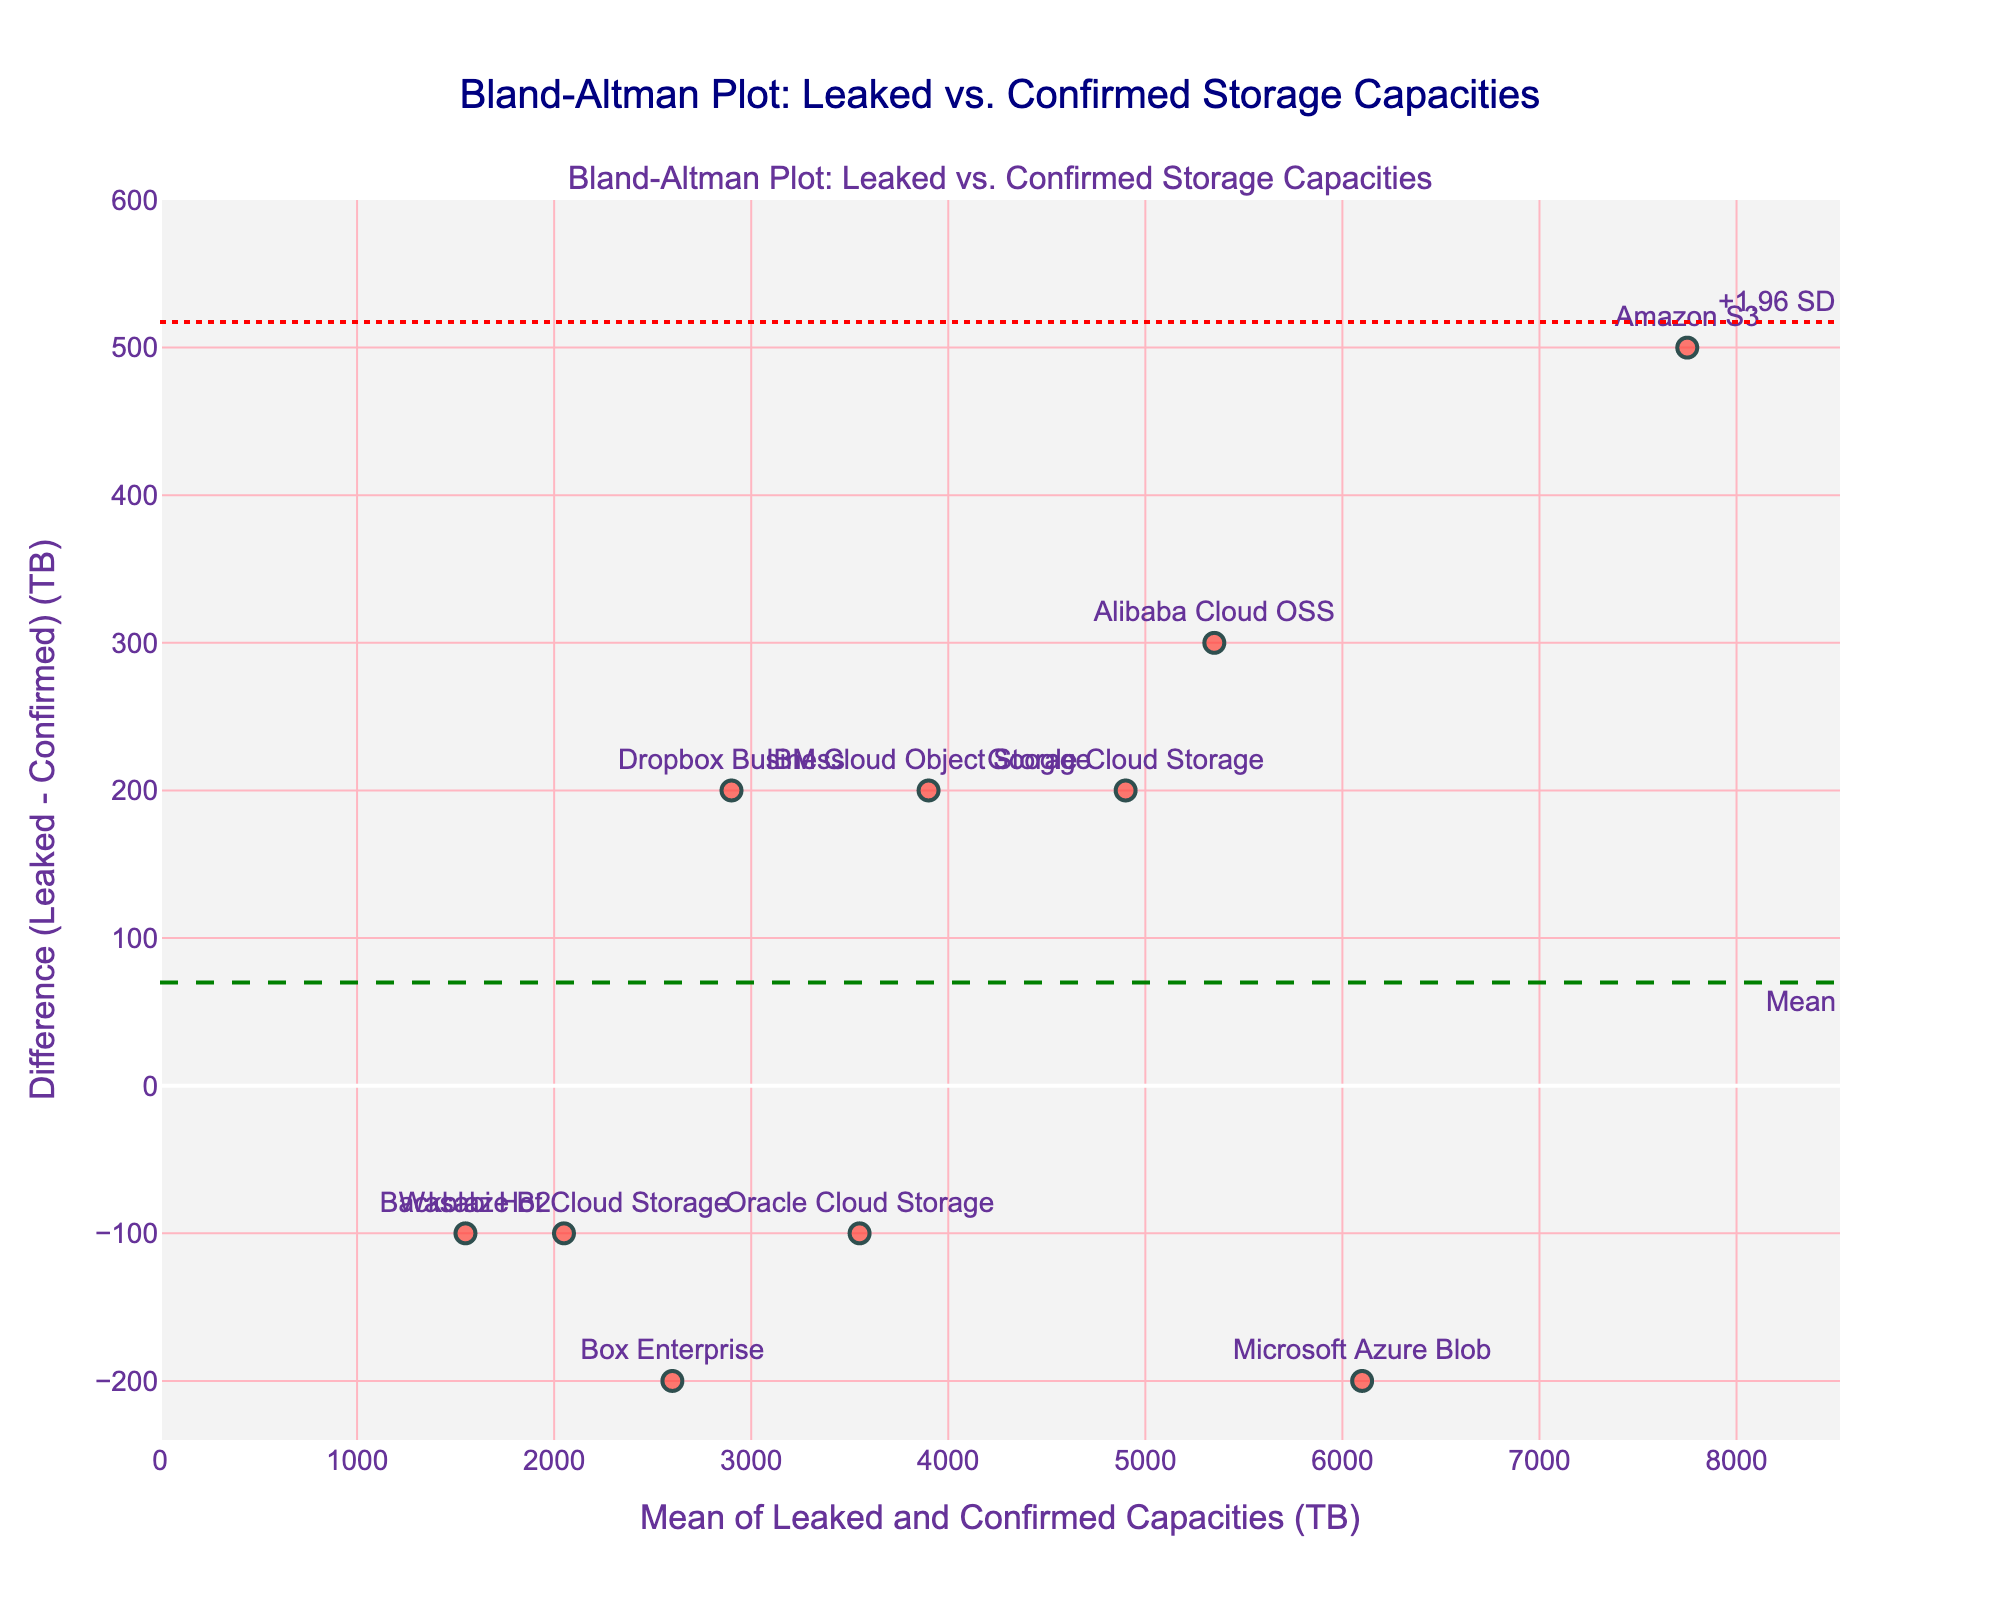What's the title of the plot? The title is usually displayed at the top of the plot in a larger font to indicate what the plot is showing.
Answer: Bland-Altman Plot: Leaked vs. Confirmed Storage Capacities How many data points are there in the plot? Each service is represented as a data point on the plot, which can be counted by looking at the number of markers on the scatter plot.
Answer: 10 What is the x-axis title of the plot? The x-axis title is shown below the horizontal axis and describes what the values along this axis represent.
Answer: Mean of Leaked and Confirmed Capacities (TB) What is the y-axis title of the plot? The y-axis title is shown next to the vertical axis and describes what the values along this axis represent.
Answer: Difference (Leaked - Confirmed) (TB) Which service has the greatest absolute difference between leaked and confirmed capacities? To find this, you need to identify the data point with the highest absolute value on the y-axis (Difference (Leaked - Confirmed) (TB)). The service label closest to this point will be the answer.
Answer: Amazon S3 What's the mean difference line's value, and what color is it? The mean difference line is usually annotated on the plot and can be identified by its color and pattern (often a dashed line). The color and value give additional context.
Answer: The mean difference line is at -60 TB and is green What are the limits of agreement in the plot? Limits of agreement are calculated as the mean difference minus and plus 1.96 times the standard deviation of the differences. These are shown as horizontal lines, often with a dotted pattern and annotated values.
Answer: -271.13 TB and 151.13 TB Which services have leaked capacities greater than confirmed capacities? These services can be found by identifying points above the zero line (positive differences) on the y-axis.
Answer: Google Cloud Storage, Amazon S3, IBM Cloud Object Storage, Alibaba Cloud OSS Which service is closest to zero difference between leaked and confirmed capacities? To find this, look for the data point which is nearest to the y = 0 line (Difference (Leaked - Confirmed) (TB)). The service label closest to this point will be the answer.
Answer: Microsoft Azure Blob Which service has the lowest mean of leaked and confirmed capacities? The service with the lowest value on the x-axis represents the lowest mean of leaked and confirmed capacities. Find the leftmost data point and its corresponding service label.
Answer: Backblaze B2 